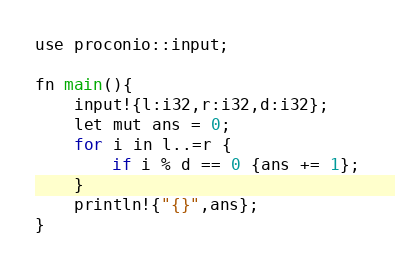<code> <loc_0><loc_0><loc_500><loc_500><_C_>use proconio::input;

fn main(){
    input!{l:i32,r:i32,d:i32};
    let mut ans = 0;
    for i in l..=r {
        if i % d == 0 {ans += 1};
    }
    println!{"{}",ans};
}</code> 